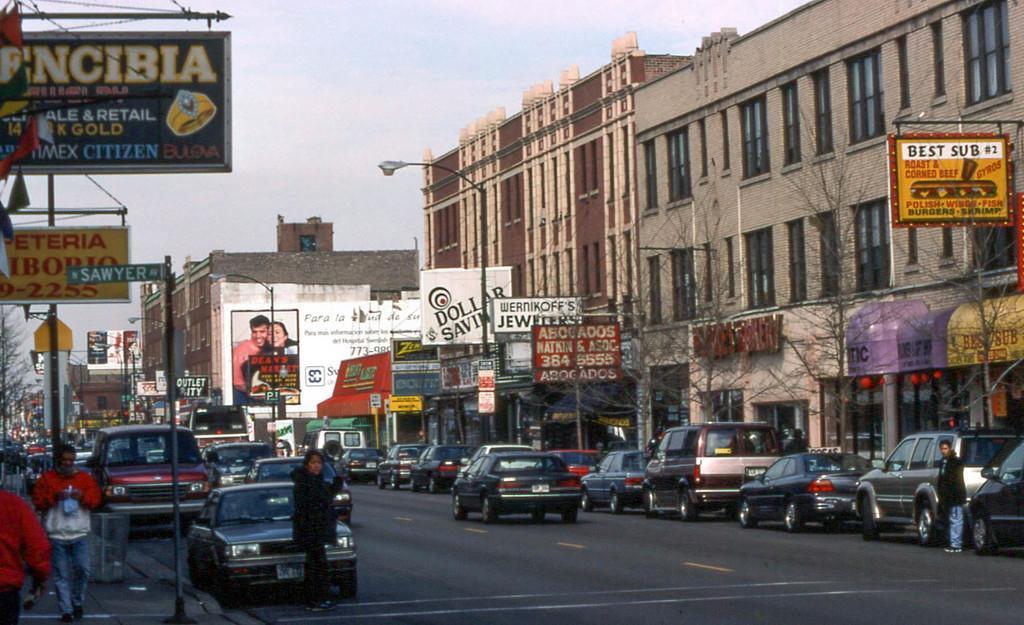Can you describe this image briefly? In this image I can see a road , on the road I can see vehicles, persons ,poles and sign boards visible ,at the top I can see the sky , on the right side I can see building , in front of the building I can see trees. On the left side I can see persons walking on the divider. 